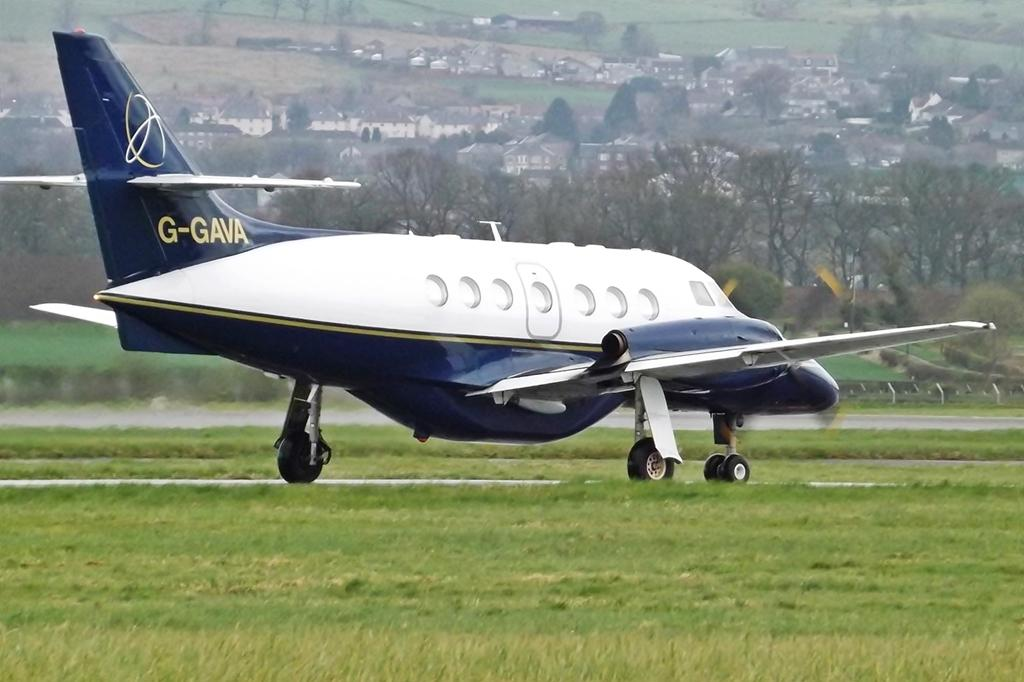Provide a one-sentence caption for the provided image. Blue and white airplane that has G-GAVA on the tail about to take off. 